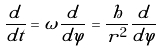Convert formula to latex. <formula><loc_0><loc_0><loc_500><loc_500>\frac { d } { d t } = \omega \frac { d } { d \varphi } = \frac { h } { r ^ { 2 } } \frac { d } { d \varphi }</formula> 